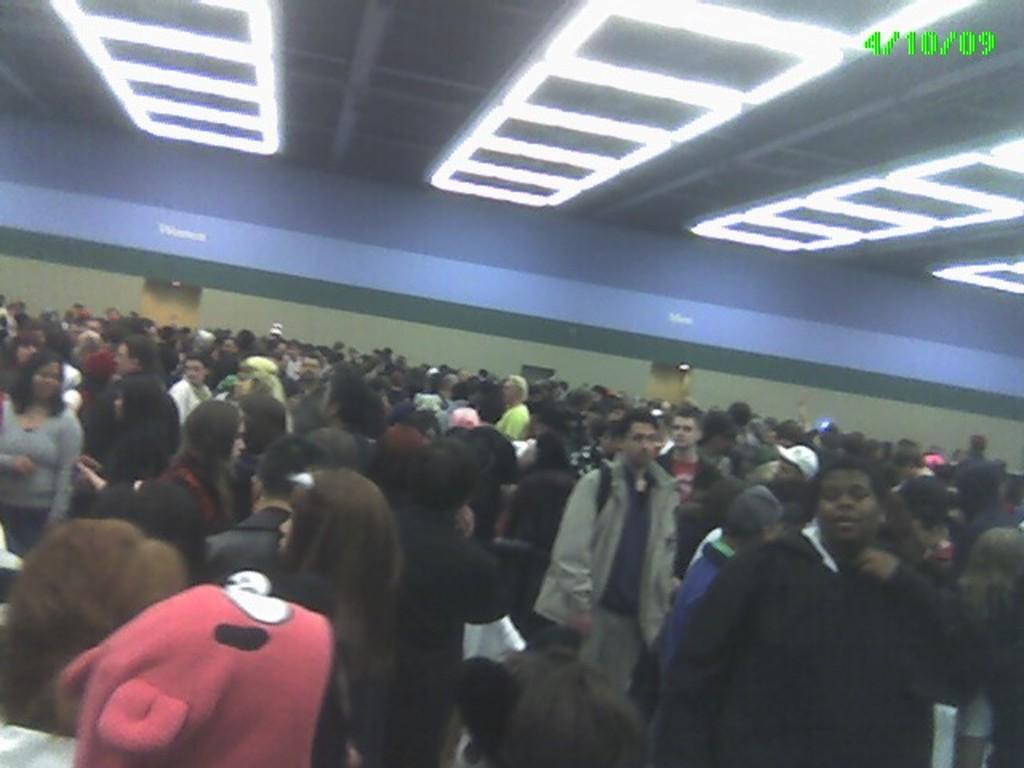Describe this image in one or two sentences. There is a crowd. On the ceiling there are lights. On the top left corner there is a watermark. 